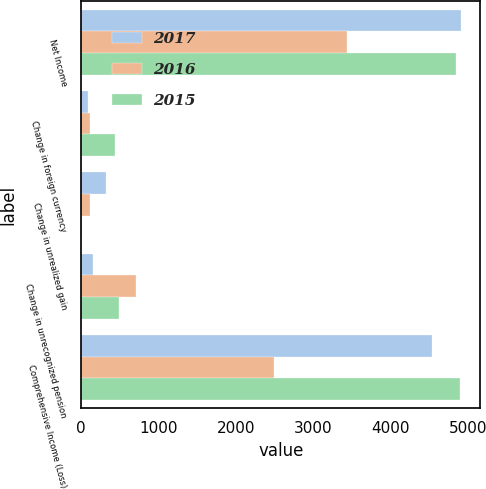<chart> <loc_0><loc_0><loc_500><loc_500><stacked_bar_chart><ecel><fcel>Net Income<fcel>Change in foreign currency<fcel>Change in unrealized gain<fcel>Change in unrecognized pension<fcel>Comprehensive Income (Loss)<nl><fcel>2017<fcel>4910<fcel>86<fcel>321<fcel>148<fcel>4526<nl><fcel>2016<fcel>3431<fcel>119<fcel>112<fcel>712<fcel>2488<nl><fcel>2015<fcel>4844<fcel>440<fcel>6<fcel>489<fcel>4898<nl></chart> 